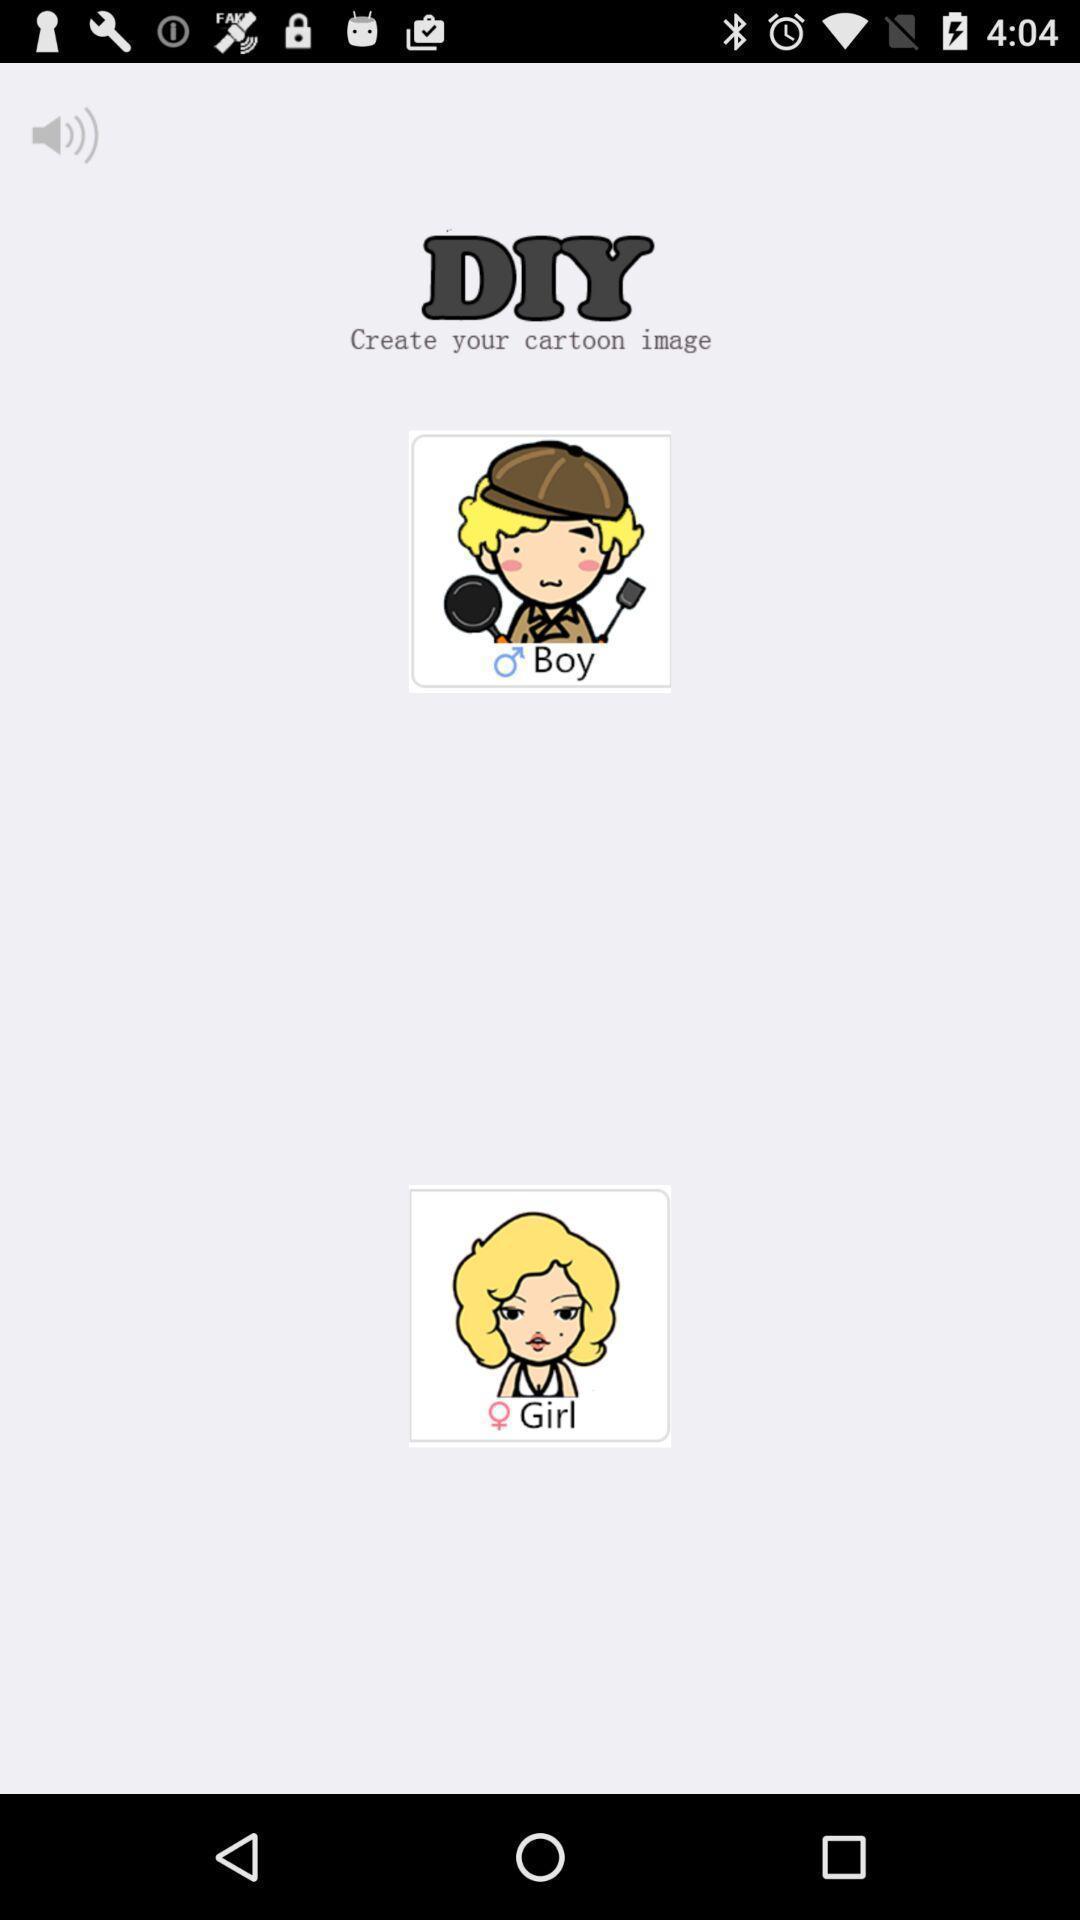Tell me about the visual elements in this screen capture. Screen shows a page about diy. 